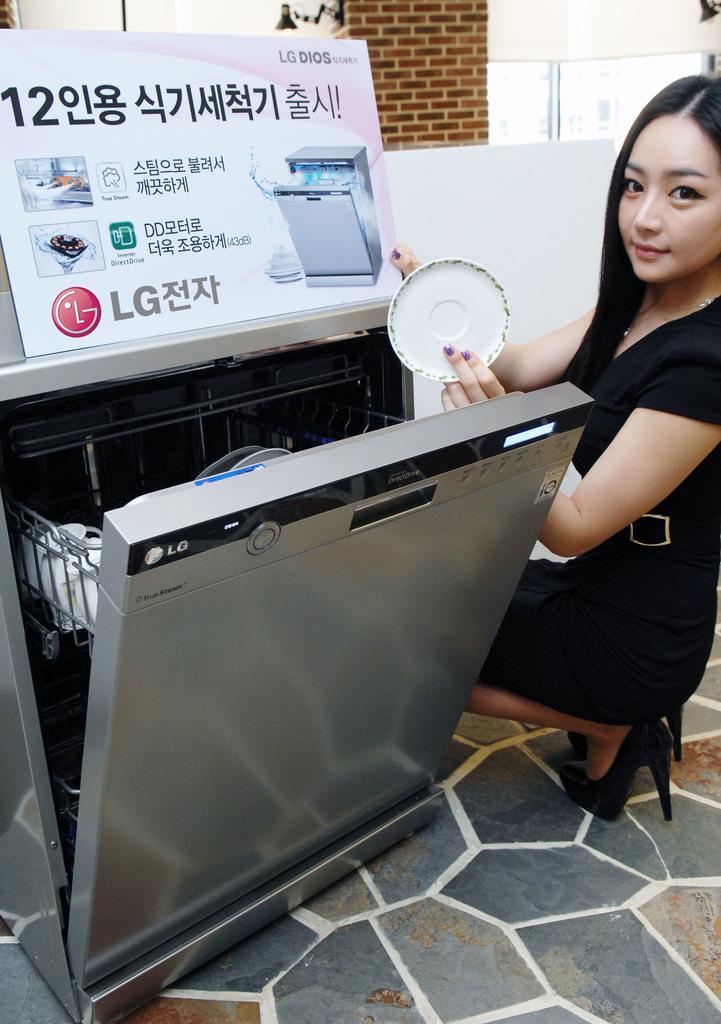What number is the top left?
Keep it short and to the point. 12. What brand is this?
Give a very brief answer. Lg. 